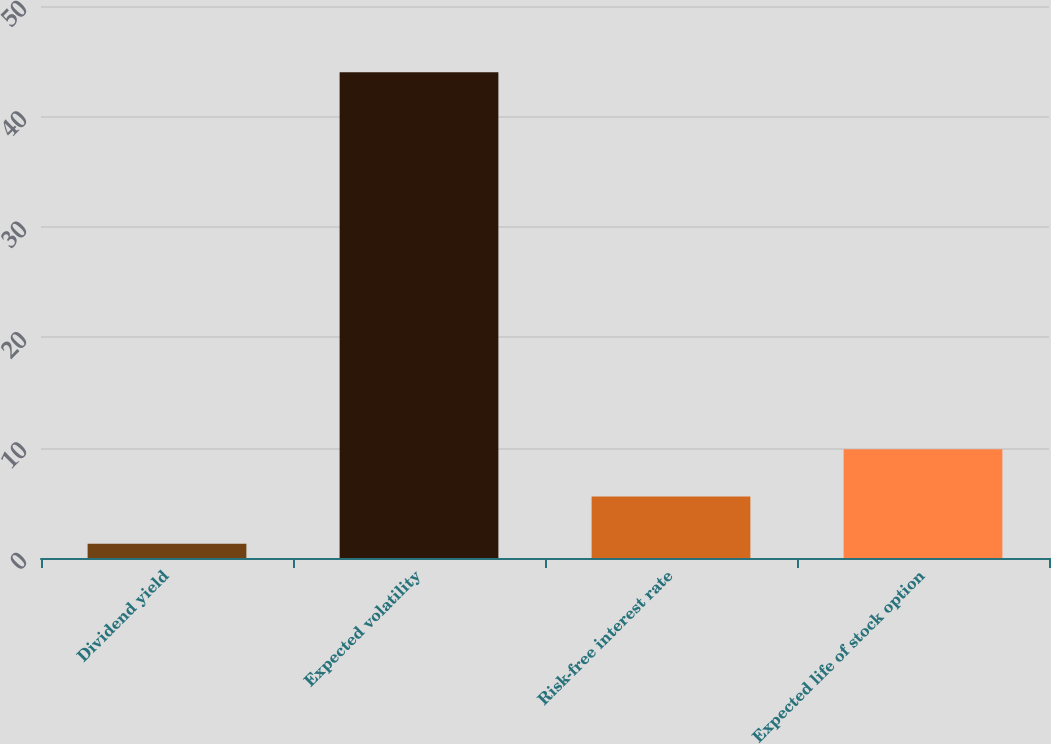Convert chart to OTSL. <chart><loc_0><loc_0><loc_500><loc_500><bar_chart><fcel>Dividend yield<fcel>Expected volatility<fcel>Risk-free interest rate<fcel>Expected life of stock option<nl><fcel>1.3<fcel>44<fcel>5.57<fcel>9.84<nl></chart> 